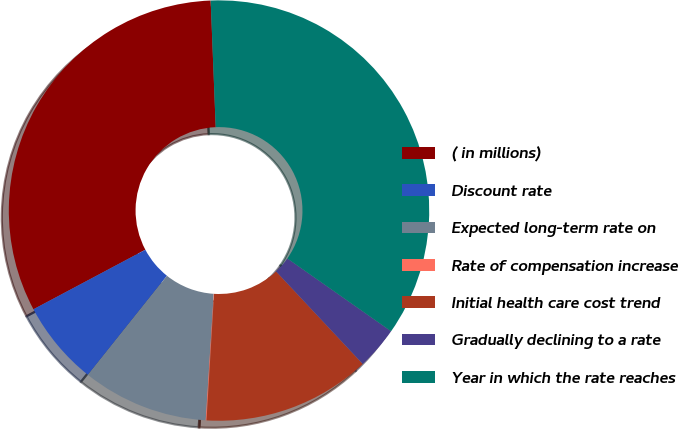Convert chart. <chart><loc_0><loc_0><loc_500><loc_500><pie_chart><fcel>( in millions)<fcel>Discount rate<fcel>Expected long-term rate on<fcel>Rate of compensation increase<fcel>Initial health care cost trend<fcel>Gradually declining to a rate<fcel>Year in which the rate reaches<nl><fcel>32.15%<fcel>6.5%<fcel>9.71%<fcel>0.06%<fcel>12.93%<fcel>3.28%<fcel>35.37%<nl></chart> 